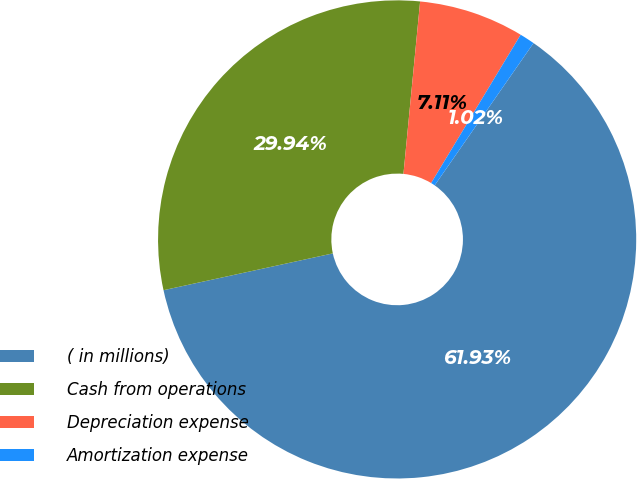Convert chart. <chart><loc_0><loc_0><loc_500><loc_500><pie_chart><fcel>( in millions)<fcel>Cash from operations<fcel>Depreciation expense<fcel>Amortization expense<nl><fcel>61.93%<fcel>29.94%<fcel>7.11%<fcel>1.02%<nl></chart> 